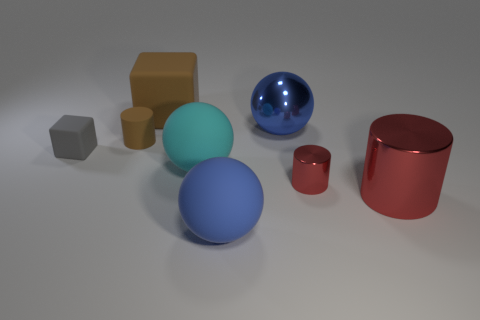Subtract all cyan cylinders. How many blue spheres are left? 2 Subtract 1 cylinders. How many cylinders are left? 2 Add 1 tiny things. How many objects exist? 9 Subtract all cylinders. How many objects are left? 5 Add 2 big purple matte cylinders. How many big purple matte cylinders exist? 2 Subtract 0 cyan blocks. How many objects are left? 8 Subtract all cyan things. Subtract all large brown rubber cubes. How many objects are left? 6 Add 7 big red metal objects. How many big red metal objects are left? 8 